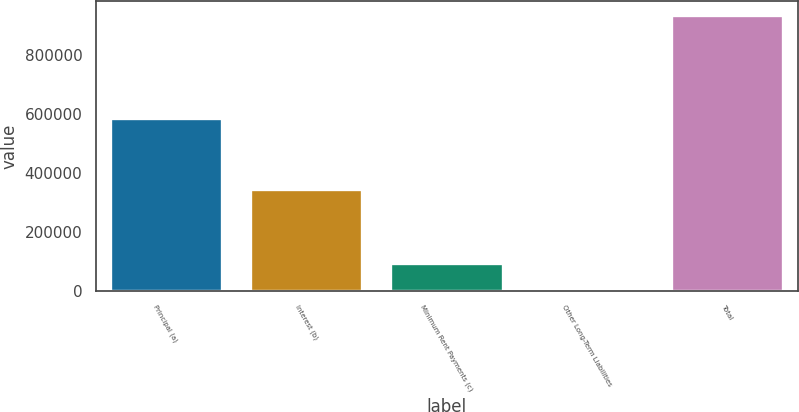Convert chart to OTSL. <chart><loc_0><loc_0><loc_500><loc_500><bar_chart><fcel>Principal (a)<fcel>Interest (b)<fcel>Minimum Rent Payments (c)<fcel>Other Long-Term Liabilities<fcel>Total<nl><fcel>584617<fcel>344599<fcel>95072.2<fcel>1677<fcel>935629<nl></chart> 